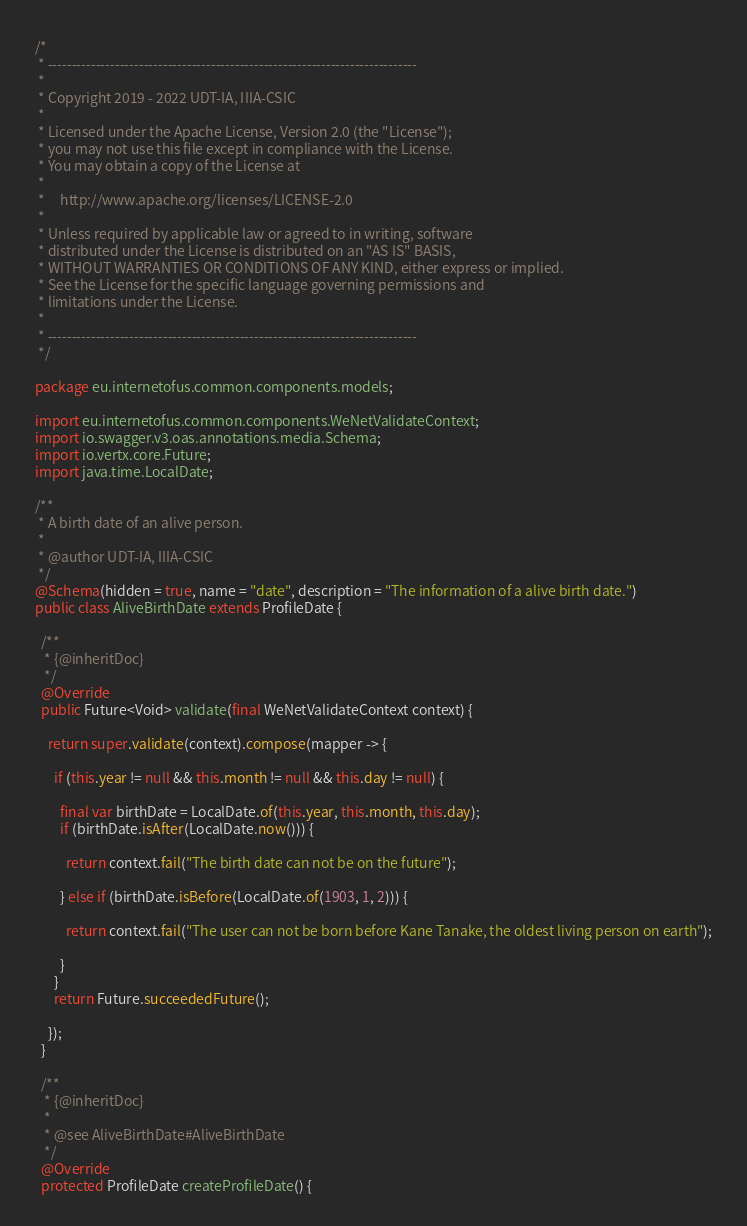Convert code to text. <code><loc_0><loc_0><loc_500><loc_500><_Java_>/*
 * -----------------------------------------------------------------------------
 *
 * Copyright 2019 - 2022 UDT-IA, IIIA-CSIC
 *
 * Licensed under the Apache License, Version 2.0 (the "License");
 * you may not use this file except in compliance with the License.
 * You may obtain a copy of the License at
 *
 *     http://www.apache.org/licenses/LICENSE-2.0
 *
 * Unless required by applicable law or agreed to in writing, software
 * distributed under the License is distributed on an "AS IS" BASIS,
 * WITHOUT WARRANTIES OR CONDITIONS OF ANY KIND, either express or implied.
 * See the License for the specific language governing permissions and
 * limitations under the License.
 *
 * -----------------------------------------------------------------------------
 */

package eu.internetofus.common.components.models;

import eu.internetofus.common.components.WeNetValidateContext;
import io.swagger.v3.oas.annotations.media.Schema;
import io.vertx.core.Future;
import java.time.LocalDate;

/**
 * A birth date of an alive person.
 *
 * @author UDT-IA, IIIA-CSIC
 */
@Schema(hidden = true, name = "date", description = "The information of a alive birth date.")
public class AliveBirthDate extends ProfileDate {

  /**
   * {@inheritDoc}
   */
  @Override
  public Future<Void> validate(final WeNetValidateContext context) {

    return super.validate(context).compose(mapper -> {

      if (this.year != null && this.month != null && this.day != null) {

        final var birthDate = LocalDate.of(this.year, this.month, this.day);
        if (birthDate.isAfter(LocalDate.now())) {

          return context.fail("The birth date can not be on the future");

        } else if (birthDate.isBefore(LocalDate.of(1903, 1, 2))) {

          return context.fail("The user can not be born before Kane Tanake, the oldest living person on earth");

        }
      }
      return Future.succeededFuture();

    });
  }

  /**
   * {@inheritDoc}
   *
   * @see AliveBirthDate#AliveBirthDate
   */
  @Override
  protected ProfileDate createProfileDate() {
</code> 